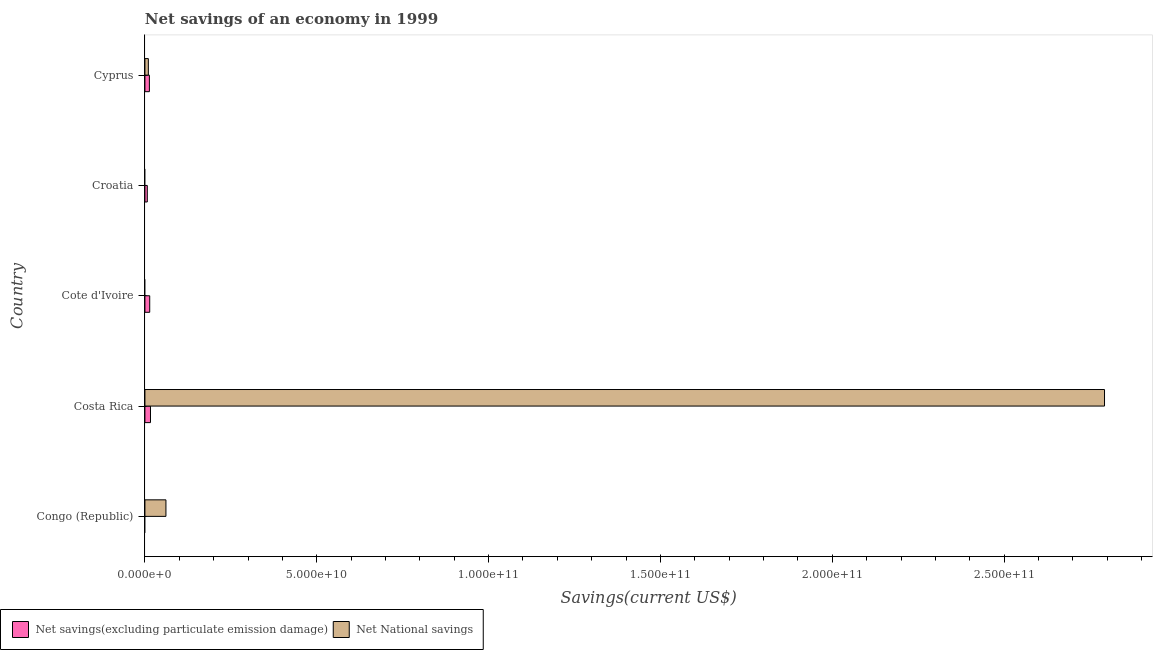How many different coloured bars are there?
Your response must be concise. 2. Are the number of bars on each tick of the Y-axis equal?
Ensure brevity in your answer.  No. How many bars are there on the 1st tick from the top?
Your answer should be very brief. 2. What is the label of the 2nd group of bars from the top?
Your answer should be very brief. Croatia. In how many cases, is the number of bars for a given country not equal to the number of legend labels?
Provide a short and direct response. 3. What is the net national savings in Cyprus?
Your answer should be very brief. 9.95e+08. Across all countries, what is the maximum net savings(excluding particulate emission damage)?
Offer a terse response. 1.62e+09. Across all countries, what is the minimum net national savings?
Ensure brevity in your answer.  0. In which country was the net savings(excluding particulate emission damage) maximum?
Keep it short and to the point. Costa Rica. What is the total net national savings in the graph?
Provide a short and direct response. 2.86e+11. What is the difference between the net national savings in Costa Rica and that in Cyprus?
Keep it short and to the point. 2.78e+11. What is the difference between the net national savings in Croatia and the net savings(excluding particulate emission damage) in Congo (Republic)?
Offer a terse response. 0. What is the average net savings(excluding particulate emission damage) per country?
Provide a short and direct response. 1.00e+09. What is the difference between the net savings(excluding particulate emission damage) and net national savings in Cyprus?
Your answer should be compact. 3.07e+08. What is the ratio of the net national savings in Congo (Republic) to that in Cyprus?
Offer a very short reply. 6.15. What is the difference between the highest and the second highest net national savings?
Your response must be concise. 2.73e+11. What is the difference between the highest and the lowest net national savings?
Provide a short and direct response. 2.79e+11. What is the difference between two consecutive major ticks on the X-axis?
Provide a succinct answer. 5.00e+1. Does the graph contain any zero values?
Keep it short and to the point. Yes. Does the graph contain grids?
Offer a terse response. No. Where does the legend appear in the graph?
Provide a succinct answer. Bottom left. How are the legend labels stacked?
Offer a very short reply. Horizontal. What is the title of the graph?
Ensure brevity in your answer.  Net savings of an economy in 1999. Does "Unregistered firms" appear as one of the legend labels in the graph?
Give a very brief answer. No. What is the label or title of the X-axis?
Offer a very short reply. Savings(current US$). What is the Savings(current US$) in Net National savings in Congo (Republic)?
Keep it short and to the point. 6.12e+09. What is the Savings(current US$) of Net savings(excluding particulate emission damage) in Costa Rica?
Your answer should be very brief. 1.62e+09. What is the Savings(current US$) of Net National savings in Costa Rica?
Your response must be concise. 2.79e+11. What is the Savings(current US$) of Net savings(excluding particulate emission damage) in Cote d'Ivoire?
Give a very brief answer. 1.40e+09. What is the Savings(current US$) of Net National savings in Cote d'Ivoire?
Offer a very short reply. 0. What is the Savings(current US$) in Net savings(excluding particulate emission damage) in Croatia?
Give a very brief answer. 6.92e+08. What is the Savings(current US$) in Net savings(excluding particulate emission damage) in Cyprus?
Make the answer very short. 1.30e+09. What is the Savings(current US$) in Net National savings in Cyprus?
Offer a terse response. 9.95e+08. Across all countries, what is the maximum Savings(current US$) in Net savings(excluding particulate emission damage)?
Your answer should be very brief. 1.62e+09. Across all countries, what is the maximum Savings(current US$) of Net National savings?
Your answer should be very brief. 2.79e+11. Across all countries, what is the minimum Savings(current US$) of Net savings(excluding particulate emission damage)?
Make the answer very short. 0. Across all countries, what is the minimum Savings(current US$) of Net National savings?
Provide a succinct answer. 0. What is the total Savings(current US$) of Net savings(excluding particulate emission damage) in the graph?
Make the answer very short. 5.01e+09. What is the total Savings(current US$) of Net National savings in the graph?
Offer a terse response. 2.86e+11. What is the difference between the Savings(current US$) in Net National savings in Congo (Republic) and that in Costa Rica?
Make the answer very short. -2.73e+11. What is the difference between the Savings(current US$) of Net National savings in Congo (Republic) and that in Cyprus?
Offer a very short reply. 5.12e+09. What is the difference between the Savings(current US$) in Net savings(excluding particulate emission damage) in Costa Rica and that in Cote d'Ivoire?
Ensure brevity in your answer.  2.22e+08. What is the difference between the Savings(current US$) in Net savings(excluding particulate emission damage) in Costa Rica and that in Croatia?
Offer a very short reply. 9.25e+08. What is the difference between the Savings(current US$) of Net savings(excluding particulate emission damage) in Costa Rica and that in Cyprus?
Your answer should be compact. 3.15e+08. What is the difference between the Savings(current US$) of Net National savings in Costa Rica and that in Cyprus?
Make the answer very short. 2.78e+11. What is the difference between the Savings(current US$) of Net savings(excluding particulate emission damage) in Cote d'Ivoire and that in Croatia?
Provide a short and direct response. 7.03e+08. What is the difference between the Savings(current US$) in Net savings(excluding particulate emission damage) in Cote d'Ivoire and that in Cyprus?
Provide a succinct answer. 9.28e+07. What is the difference between the Savings(current US$) in Net savings(excluding particulate emission damage) in Croatia and that in Cyprus?
Ensure brevity in your answer.  -6.10e+08. What is the difference between the Savings(current US$) in Net savings(excluding particulate emission damage) in Costa Rica and the Savings(current US$) in Net National savings in Cyprus?
Keep it short and to the point. 6.22e+08. What is the difference between the Savings(current US$) in Net savings(excluding particulate emission damage) in Cote d'Ivoire and the Savings(current US$) in Net National savings in Cyprus?
Provide a short and direct response. 4.00e+08. What is the difference between the Savings(current US$) in Net savings(excluding particulate emission damage) in Croatia and the Savings(current US$) in Net National savings in Cyprus?
Your response must be concise. -3.03e+08. What is the average Savings(current US$) of Net savings(excluding particulate emission damage) per country?
Your answer should be very brief. 1.00e+09. What is the average Savings(current US$) in Net National savings per country?
Your answer should be compact. 5.73e+1. What is the difference between the Savings(current US$) in Net savings(excluding particulate emission damage) and Savings(current US$) in Net National savings in Costa Rica?
Your response must be concise. -2.78e+11. What is the difference between the Savings(current US$) of Net savings(excluding particulate emission damage) and Savings(current US$) of Net National savings in Cyprus?
Your response must be concise. 3.07e+08. What is the ratio of the Savings(current US$) in Net National savings in Congo (Republic) to that in Costa Rica?
Your answer should be very brief. 0.02. What is the ratio of the Savings(current US$) in Net National savings in Congo (Republic) to that in Cyprus?
Give a very brief answer. 6.15. What is the ratio of the Savings(current US$) of Net savings(excluding particulate emission damage) in Costa Rica to that in Cote d'Ivoire?
Provide a succinct answer. 1.16. What is the ratio of the Savings(current US$) of Net savings(excluding particulate emission damage) in Costa Rica to that in Croatia?
Your response must be concise. 2.34. What is the ratio of the Savings(current US$) in Net savings(excluding particulate emission damage) in Costa Rica to that in Cyprus?
Provide a succinct answer. 1.24. What is the ratio of the Savings(current US$) in Net National savings in Costa Rica to that in Cyprus?
Offer a terse response. 280.6. What is the ratio of the Savings(current US$) in Net savings(excluding particulate emission damage) in Cote d'Ivoire to that in Croatia?
Your answer should be compact. 2.02. What is the ratio of the Savings(current US$) of Net savings(excluding particulate emission damage) in Cote d'Ivoire to that in Cyprus?
Provide a succinct answer. 1.07. What is the ratio of the Savings(current US$) of Net savings(excluding particulate emission damage) in Croatia to that in Cyprus?
Your answer should be compact. 0.53. What is the difference between the highest and the second highest Savings(current US$) in Net savings(excluding particulate emission damage)?
Offer a very short reply. 2.22e+08. What is the difference between the highest and the second highest Savings(current US$) in Net National savings?
Offer a very short reply. 2.73e+11. What is the difference between the highest and the lowest Savings(current US$) of Net savings(excluding particulate emission damage)?
Your answer should be very brief. 1.62e+09. What is the difference between the highest and the lowest Savings(current US$) in Net National savings?
Offer a terse response. 2.79e+11. 